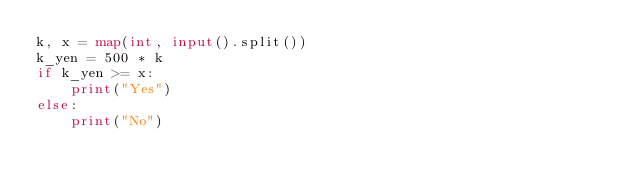Convert code to text. <code><loc_0><loc_0><loc_500><loc_500><_Python_>k, x = map(int, input().split())
k_yen = 500 * k
if k_yen >= x:
    print("Yes")
else:
    print("No")</code> 